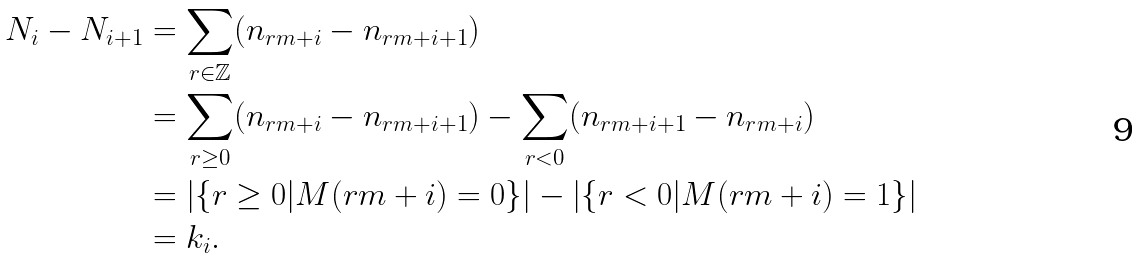<formula> <loc_0><loc_0><loc_500><loc_500>N _ { i } - N _ { i + 1 } & = \sum _ { r \in \mathbb { Z } } ( n _ { r m + i } - n _ { r m + i + 1 } ) \\ & = \sum _ { r \geq 0 } ( n _ { r m + i } - n _ { r m + i + 1 } ) - \sum _ { r < 0 } ( n _ { r m + i + 1 } - n _ { r m + i } ) \\ & = | \{ r \geq 0 | M ( r m + i ) = 0 \} | - | \{ r < 0 | M ( r m + i ) = 1 \} | \\ & = k _ { i } .</formula> 